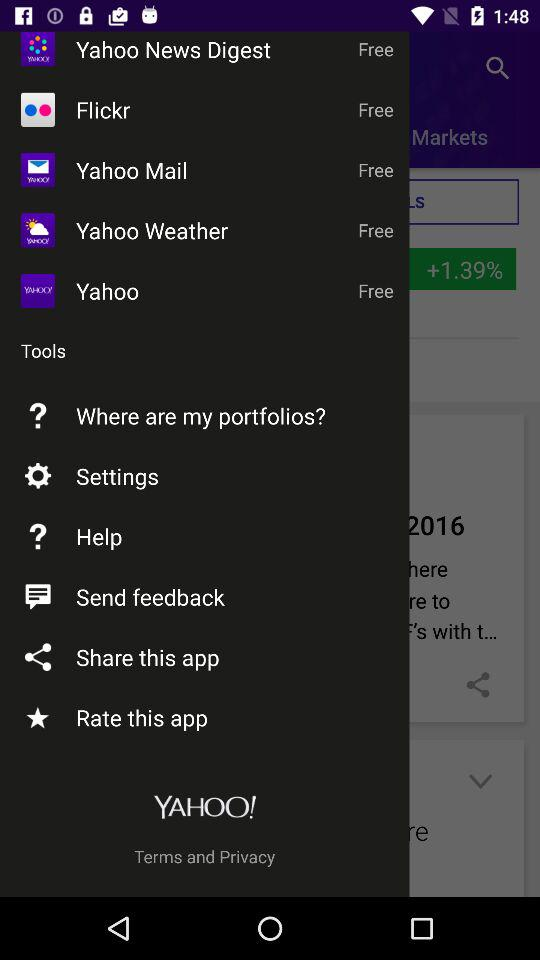What are the names of the available free applications? The names of the available free applications are "Yahoo News Digest", "Flickr", "Yahoo Mail", "Yahoo Weather" and "Yahoo". 